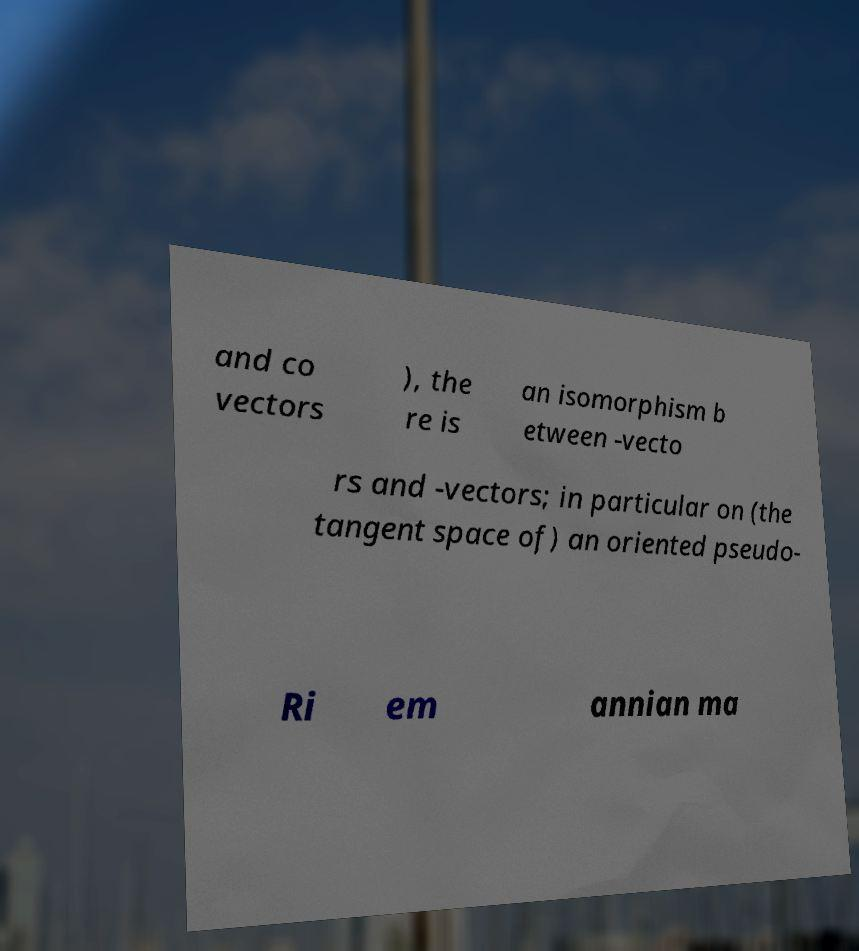Could you assist in decoding the text presented in this image and type it out clearly? and co vectors ), the re is an isomorphism b etween -vecto rs and -vectors; in particular on (the tangent space of) an oriented pseudo- Ri em annian ma 